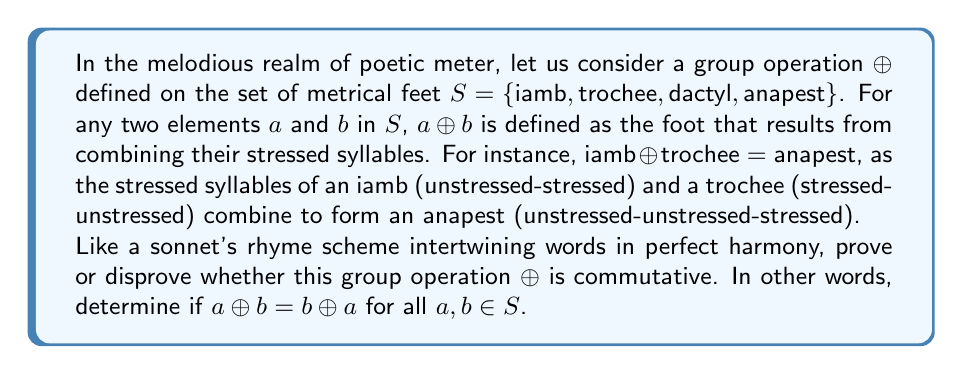Help me with this question. To determine whether the group operation ⊕ is commutative, we must examine if a ⊕ b = b ⊕ a holds true for all possible combinations of elements in the set S. Let us embark on this poetic journey step by step:

1. First, let's define the stress patterns of each metrical foot:
   - Iamb: unstressed-stressed (∪-)
   - Trochee: stressed-unstressed (-∪)
   - Dactyl: stressed-unstressed-unstressed (-∪∪)
   - Anapest: unstressed-unstressed-stressed (∪∪-)

2. Now, let's consider all possible combinations:

   a) Iamb ⊕ Trochee:
      Iamb (∪-) ⊕ Trochee (-∪) = Anapest (∪∪-)
      Trochee (-∪) ⊕ Iamb (∪-) = Anapest (∪∪-)
      Result: Commutative

   b) Iamb ⊕ Dactyl:
      Iamb (∪-) ⊕ Dactyl (-∪∪) = Anapest (∪∪-)
      Dactyl (-∪∪) ⊕ Iamb (∪-) = Dactyl (-∪∪)
      Result: Not commutative

   c) Iamb ⊕ Anapest:
      Iamb (∪-) ⊕ Anapest (∪∪-) = Anapest (∪∪-)
      Anapest (∪∪-) ⊕ Iamb (∪-) = Anapest (∪∪-)
      Result: Commutative

   d) Trochee ⊕ Dactyl:
      Trochee (-∪) ⊕ Dactyl (-∪∪) = Dactyl (-∪∪)
      Dactyl (-∪∪) ⊕ Trochee (-∪) = Dactyl (-∪∪)
      Result: Commutative

   e) Trochee ⊕ Anapest:
      Trochee (-∪) ⊕ Anapest (∪∪-) = Dactyl (-∪∪)
      Anapest (∪∪-) ⊕ Trochee (-∪) = Anapest (∪∪-)
      Result: Not commutative

   f) Dactyl ⊕ Anapest:
      Dactyl (-∪∪) ⊕ Anapest (∪∪-) = Dactyl (-∪∪)
      Anapest (∪∪-) ⊕ Dactyl (-∪∪) = Anapest (∪∪-)
      Result: Not commutative

3. We have found multiple instances where a ⊕ b ≠ b ⊕ a. Specifically, in cases b, e, and f.

4. For a group operation to be commutative, it must hold true for all possible combinations of elements in the set. Since we have found counterexamples, we can conclude that the operation is not commutative.

Thus, like a tragic hero's fatal flaw unraveling the tapestry of their fate, we have discovered that this poetic group operation does not possess the melodious symmetry of commutativity.
Answer: The group operation ⊕ based on poetic meter is not commutative. There exist elements a, b ∈ S such that a ⊕ b ≠ b ⊕ a, as demonstrated by the counterexamples: Iamb ⊕ Dactyl ≠ Dactyl ⊕ Iamb, Trochee ⊕ Anapest ≠ Anapest ⊕ Trochee, and Dactyl ⊕ Anapest ≠ Anapest ⊕ Dactyl. 